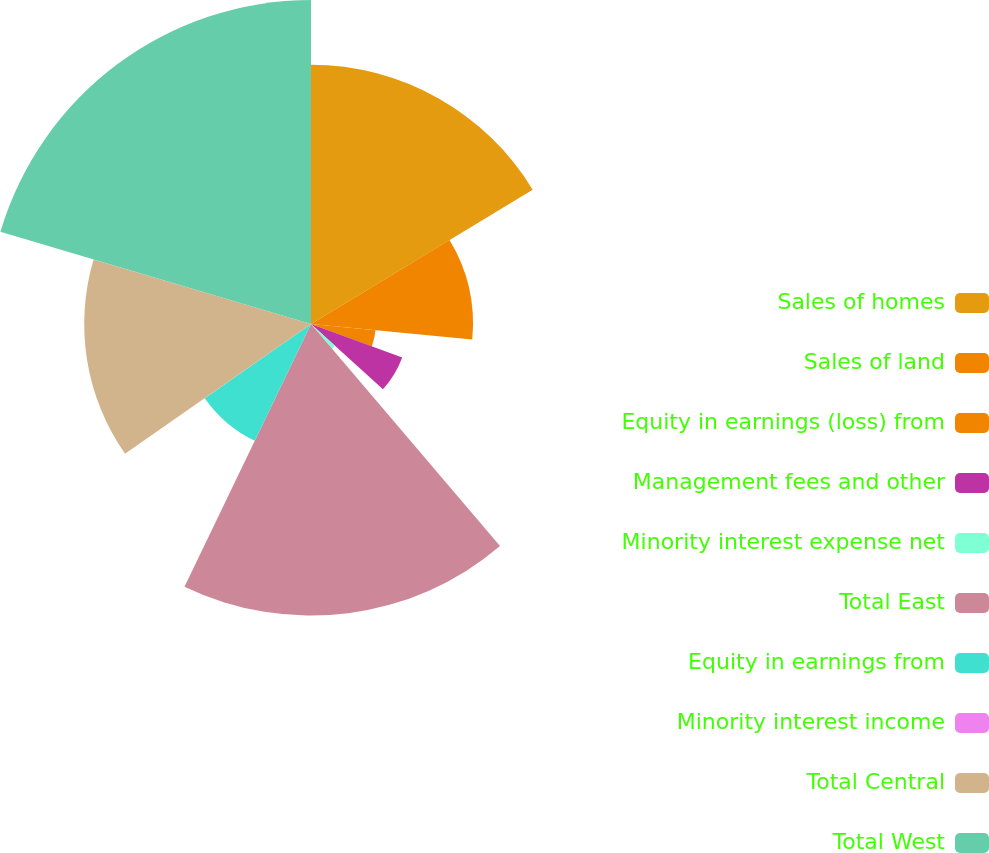Convert chart to OTSL. <chart><loc_0><loc_0><loc_500><loc_500><pie_chart><fcel>Sales of homes<fcel>Sales of land<fcel>Equity in earnings (loss) from<fcel>Management fees and other<fcel>Minority interest expense net<fcel>Total East<fcel>Equity in earnings from<fcel>Minority interest income<fcel>Total Central<fcel>Total West<nl><fcel>16.32%<fcel>10.2%<fcel>4.08%<fcel>6.12%<fcel>2.04%<fcel>18.36%<fcel>8.16%<fcel>0.0%<fcel>14.28%<fcel>20.4%<nl></chart> 